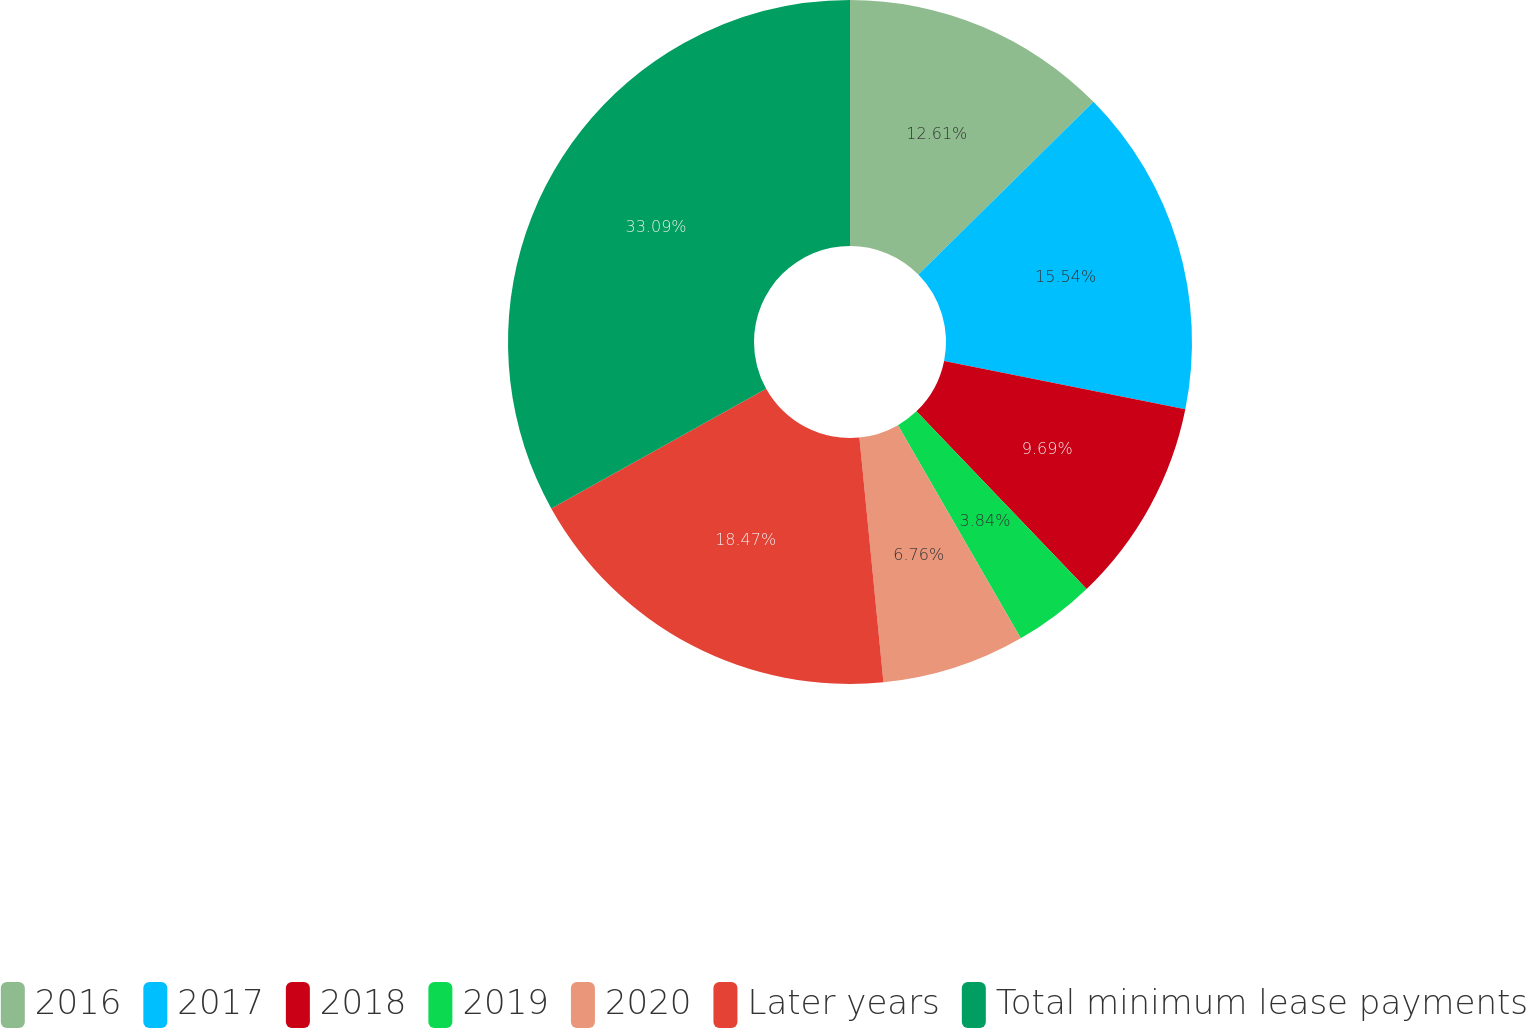Convert chart to OTSL. <chart><loc_0><loc_0><loc_500><loc_500><pie_chart><fcel>2016<fcel>2017<fcel>2018<fcel>2019<fcel>2020<fcel>Later years<fcel>Total minimum lease payments<nl><fcel>12.61%<fcel>15.54%<fcel>9.69%<fcel>3.84%<fcel>6.76%<fcel>18.47%<fcel>33.09%<nl></chart> 